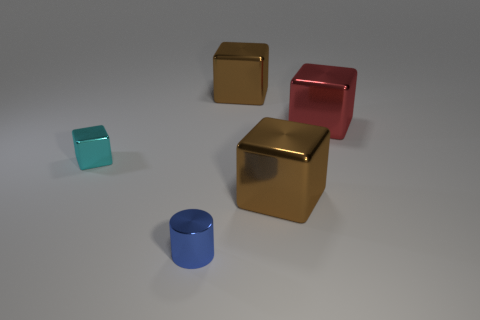Subtract all purple blocks. Subtract all yellow cylinders. How many blocks are left? 4 Add 4 big red metal cubes. How many objects exist? 9 Subtract all cylinders. How many objects are left? 4 Subtract all big purple cylinders. Subtract all large brown shiny blocks. How many objects are left? 3 Add 1 blue metal cylinders. How many blue metal cylinders are left? 2 Add 2 tiny cubes. How many tiny cubes exist? 3 Subtract 0 purple blocks. How many objects are left? 5 